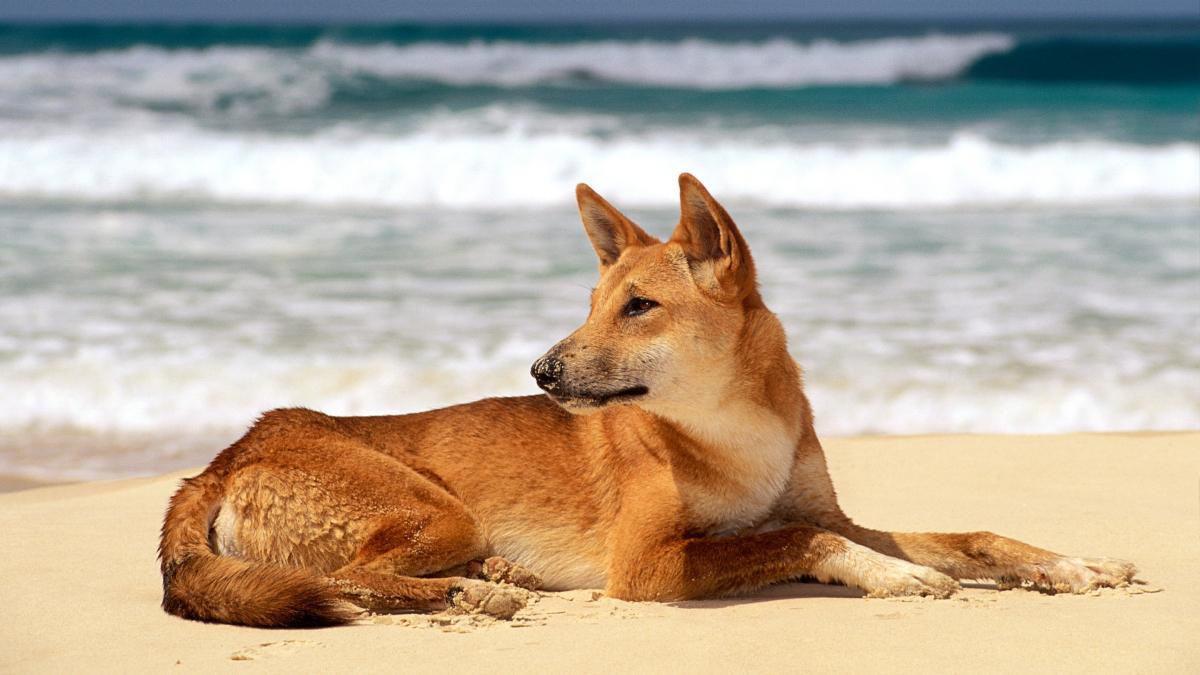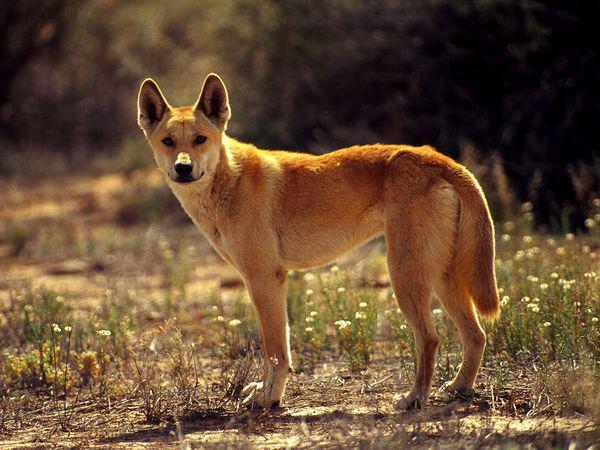The first image is the image on the left, the second image is the image on the right. For the images shown, is this caption "There are no more than 2 dogs per image pair" true? Answer yes or no. Yes. The first image is the image on the left, the second image is the image on the right. Evaluate the accuracy of this statement regarding the images: "In at least one image, there are no less than two yellow and white canines standing.". Is it true? Answer yes or no. No. 